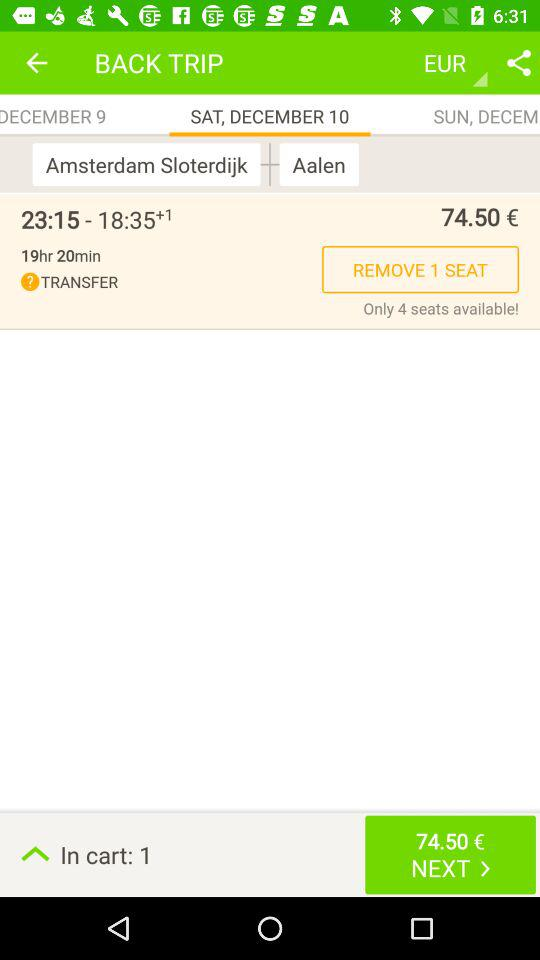What is the travel time from "Amsterdam Sloterdijk" to "Aalen"? The travel time from "Amsterdam Sloterdijk" to "Aalen" is 19 hours 20 minutes. 